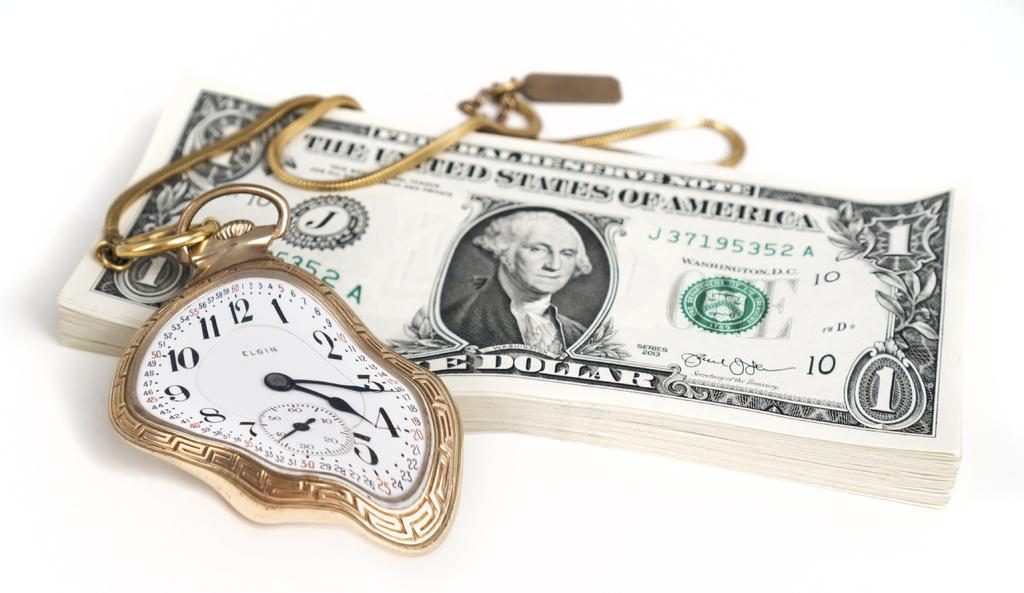<image>
Render a clear and concise summary of the photo. A Federal Reserve Note from The United States of America, One Dollar bill stack with a gold pocket watch that lays on top of it. 